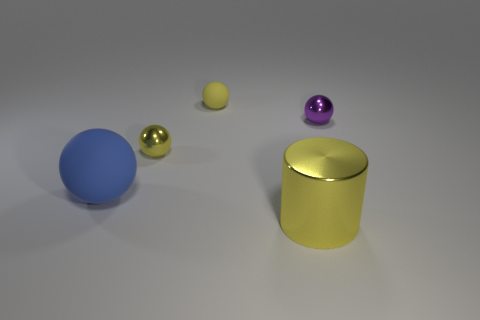Does the big ball have the same color as the large shiny cylinder?
Keep it short and to the point. No. How many big shiny things are behind the small matte thing?
Your answer should be very brief. 0. There is a thing that is made of the same material as the large blue ball; what color is it?
Give a very brief answer. Yellow. How many shiny things are either small purple things or big cylinders?
Offer a terse response. 2. Does the tiny purple ball have the same material as the cylinder?
Provide a short and direct response. Yes. There is a yellow metal thing that is in front of the blue matte ball; what is its shape?
Ensure brevity in your answer.  Cylinder. Are there any large metallic cylinders that are behind the large blue matte ball that is in front of the tiny purple metal ball?
Offer a terse response. No. Is there a purple metallic sphere that has the same size as the yellow rubber sphere?
Ensure brevity in your answer.  Yes. There is a matte sphere that is to the left of the yellow matte sphere; is it the same color as the small matte object?
Offer a terse response. No. The cylinder is what size?
Offer a terse response. Large. 